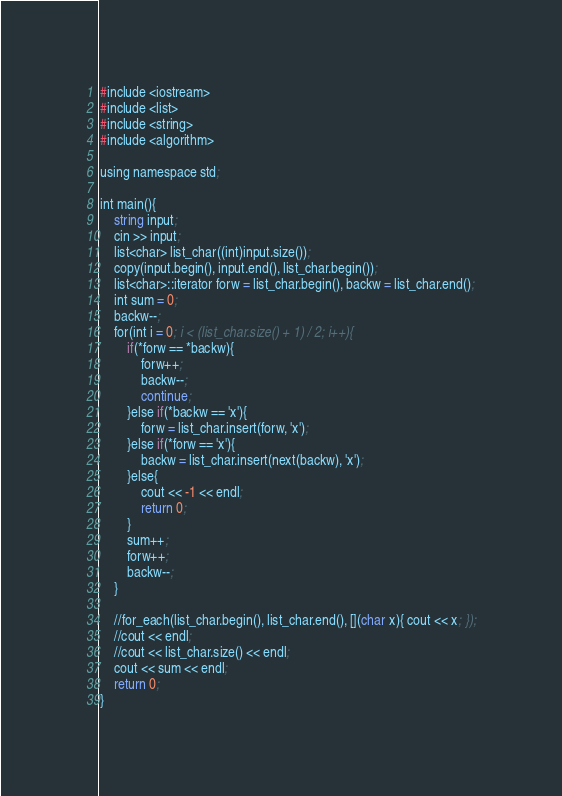Convert code to text. <code><loc_0><loc_0><loc_500><loc_500><_Lisp_>#include <iostream>
#include <list>
#include <string>
#include <algorithm>

using namespace std;

int main(){
    string input;
    cin >> input;
    list<char> list_char((int)input.size());
    copy(input.begin(), input.end(), list_char.begin());
    list<char>::iterator forw = list_char.begin(), backw = list_char.end();
    int sum = 0;
    backw--;
    for(int i = 0; i < (list_char.size() + 1) / 2; i++){
        if(*forw == *backw){
            forw++;
            backw--;
            continue;
        }else if(*backw == 'x'){
            forw = list_char.insert(forw, 'x');
        }else if(*forw == 'x'){
            backw = list_char.insert(next(backw), 'x');
        }else{
            cout << -1 << endl;
            return 0;
        }
        sum++;
        forw++;
        backw--;
    }
    
    //for_each(list_char.begin(), list_char.end(), [](char x){ cout << x; });
    //cout << endl;
    //cout << list_char.size() << endl;
    cout << sum << endl;
    return 0;
}
</code> 